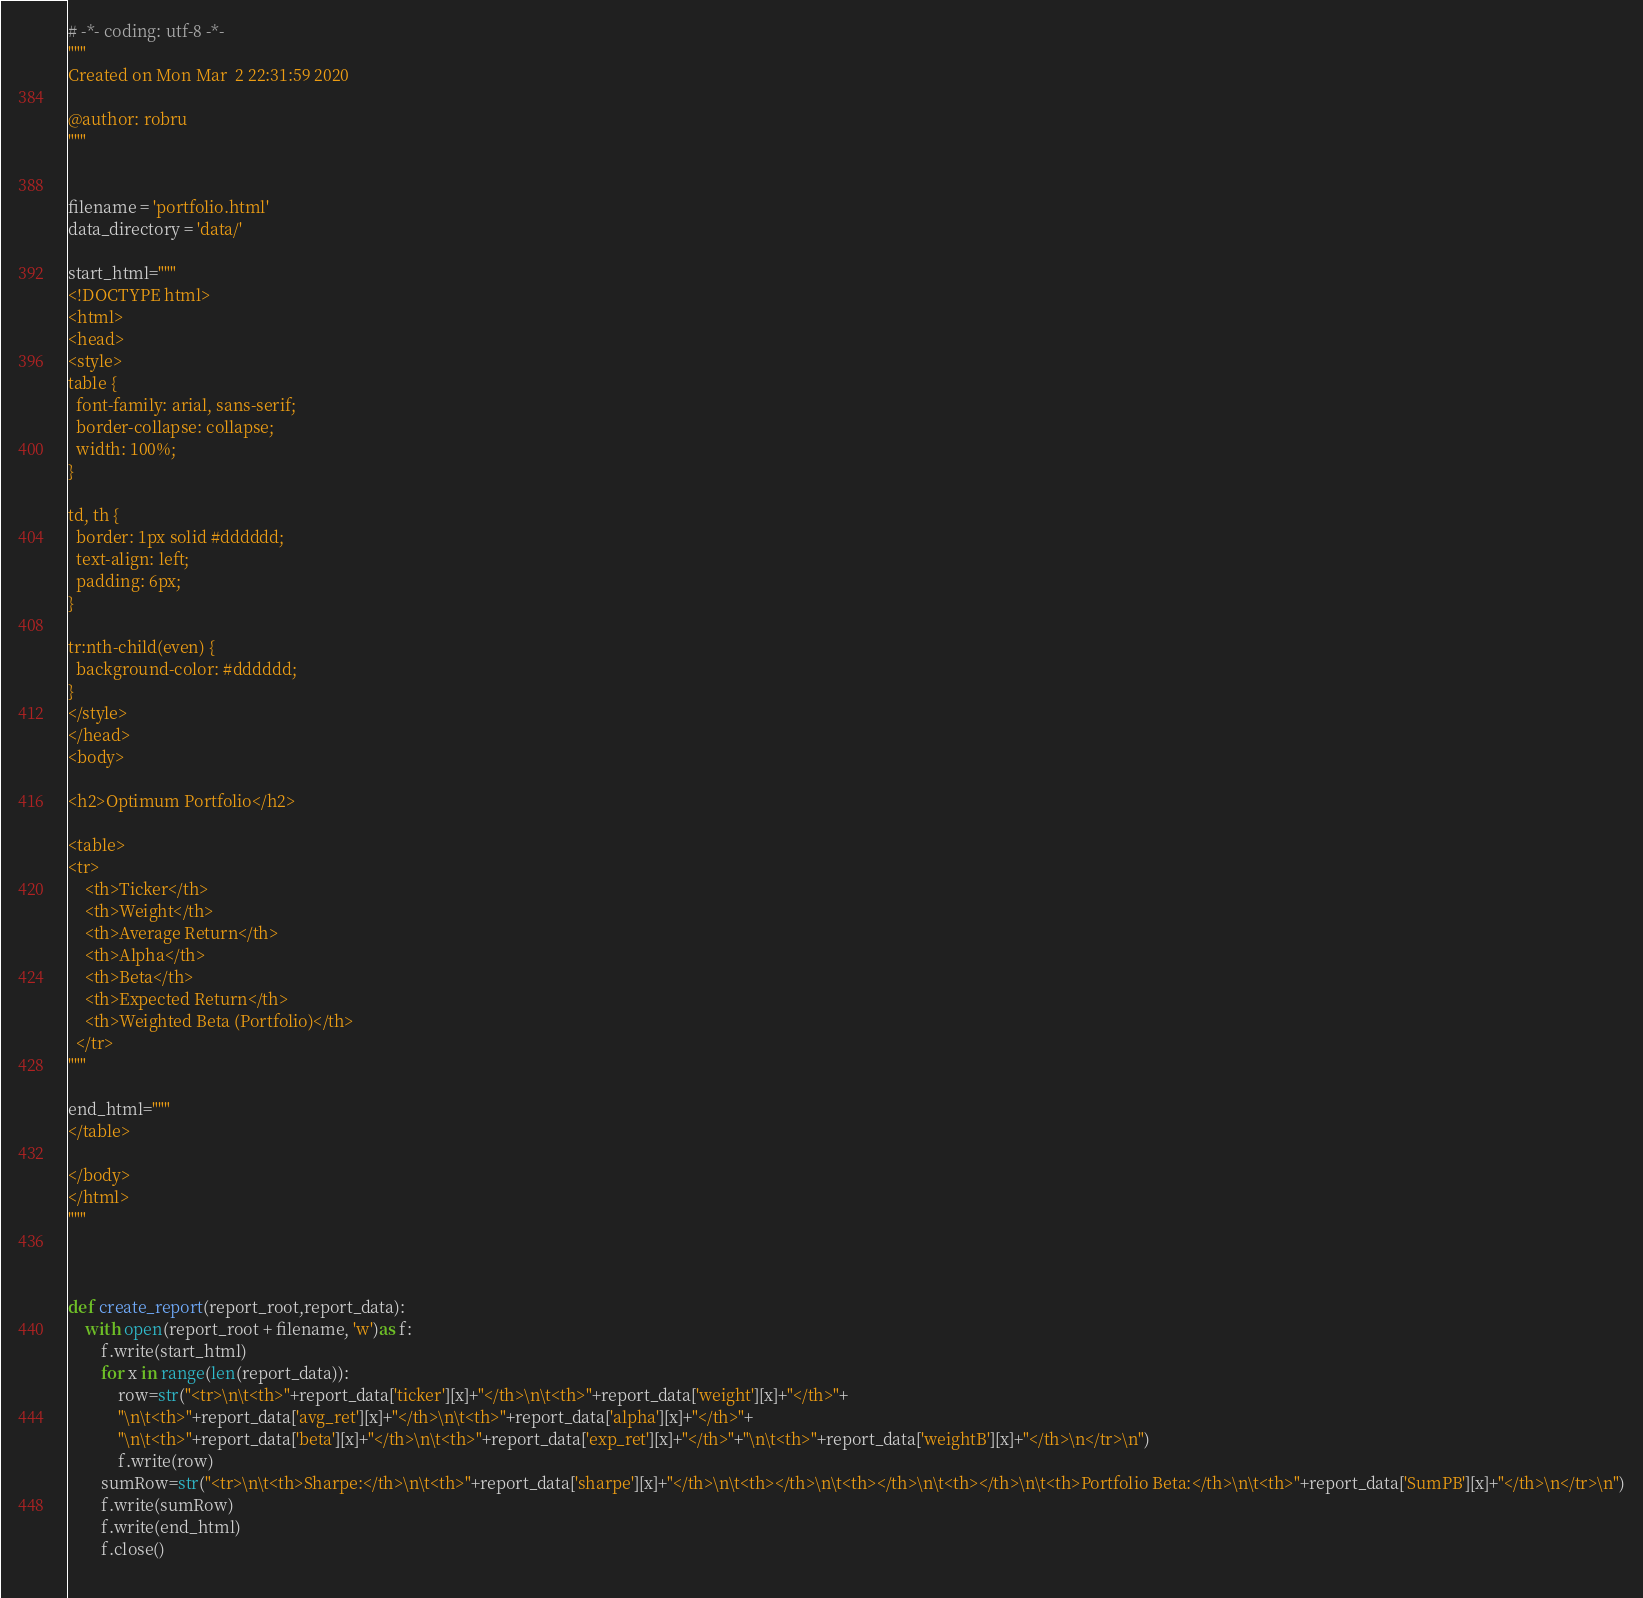<code> <loc_0><loc_0><loc_500><loc_500><_Python_># -*- coding: utf-8 -*-
"""
Created on Mon Mar  2 22:31:59 2020

@author: robru
"""


filename = 'portfolio.html'
data_directory = 'data/'

start_html="""   
<!DOCTYPE html>
<html>
<head>
<style>
table {
  font-family: arial, sans-serif;
  border-collapse: collapse;
  width: 100%;
}

td, th {
  border: 1px solid #dddddd;
  text-align: left;
  padding: 6px;
}

tr:nth-child(even) {
  background-color: #dddddd;
}
</style>
</head>
<body>

<h2>Optimum Portfolio</h2>

<table>
<tr>
    <th>Ticker</th>
    <th>Weight</th>
    <th>Average Return</th>
    <th>Alpha</th>
    <th>Beta</th>
    <th>Expected Return</th>
    <th>Weighted Beta (Portfolio)</th>
  </tr>
"""

end_html="""
</table>

</body>
</html>
"""



def create_report(report_root,report_data):
    with open(report_root + filename, 'w')as f:
        f.write(start_html)
        for x in range(len(report_data)):
            row=str("<tr>\n\t<th>"+report_data['ticker'][x]+"</th>\n\t<th>"+report_data['weight'][x]+"</th>"+   
            "\n\t<th>"+report_data['avg_ret'][x]+"</th>\n\t<th>"+report_data['alpha'][x]+"</th>"+
            "\n\t<th>"+report_data['beta'][x]+"</th>\n\t<th>"+report_data['exp_ret'][x]+"</th>"+"\n\t<th>"+report_data['weightB'][x]+"</th>\n</tr>\n")
            f.write(row)
        sumRow=str("<tr>\n\t<th>Sharpe:</th>\n\t<th>"+report_data['sharpe'][x]+"</th>\n\t<th></th>\n\t<th></th>\n\t<th></th>\n\t<th>Portfolio Beta:</th>\n\t<th>"+report_data['SumPB'][x]+"</th>\n</tr>\n")
        f.write(sumRow)
        f.write(end_html)
        f.close()
        
</code> 